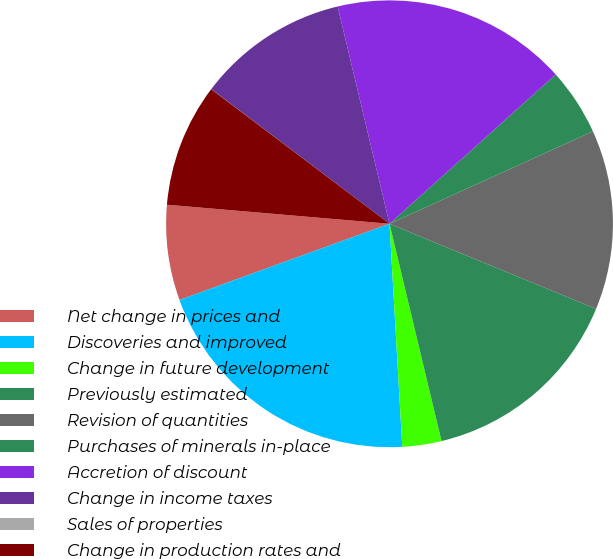Convert chart to OTSL. <chart><loc_0><loc_0><loc_500><loc_500><pie_chart><fcel>Net change in prices and<fcel>Discoveries and improved<fcel>Change in future development<fcel>Previously estimated<fcel>Revision of quantities<fcel>Purchases of minerals in-place<fcel>Accretion of discount<fcel>Change in income taxes<fcel>Sales of properties<fcel>Change in production rates and<nl><fcel>6.9%<fcel>20.37%<fcel>2.83%<fcel>15.04%<fcel>13.01%<fcel>4.86%<fcel>17.08%<fcel>10.97%<fcel>0.01%<fcel>8.93%<nl></chart> 